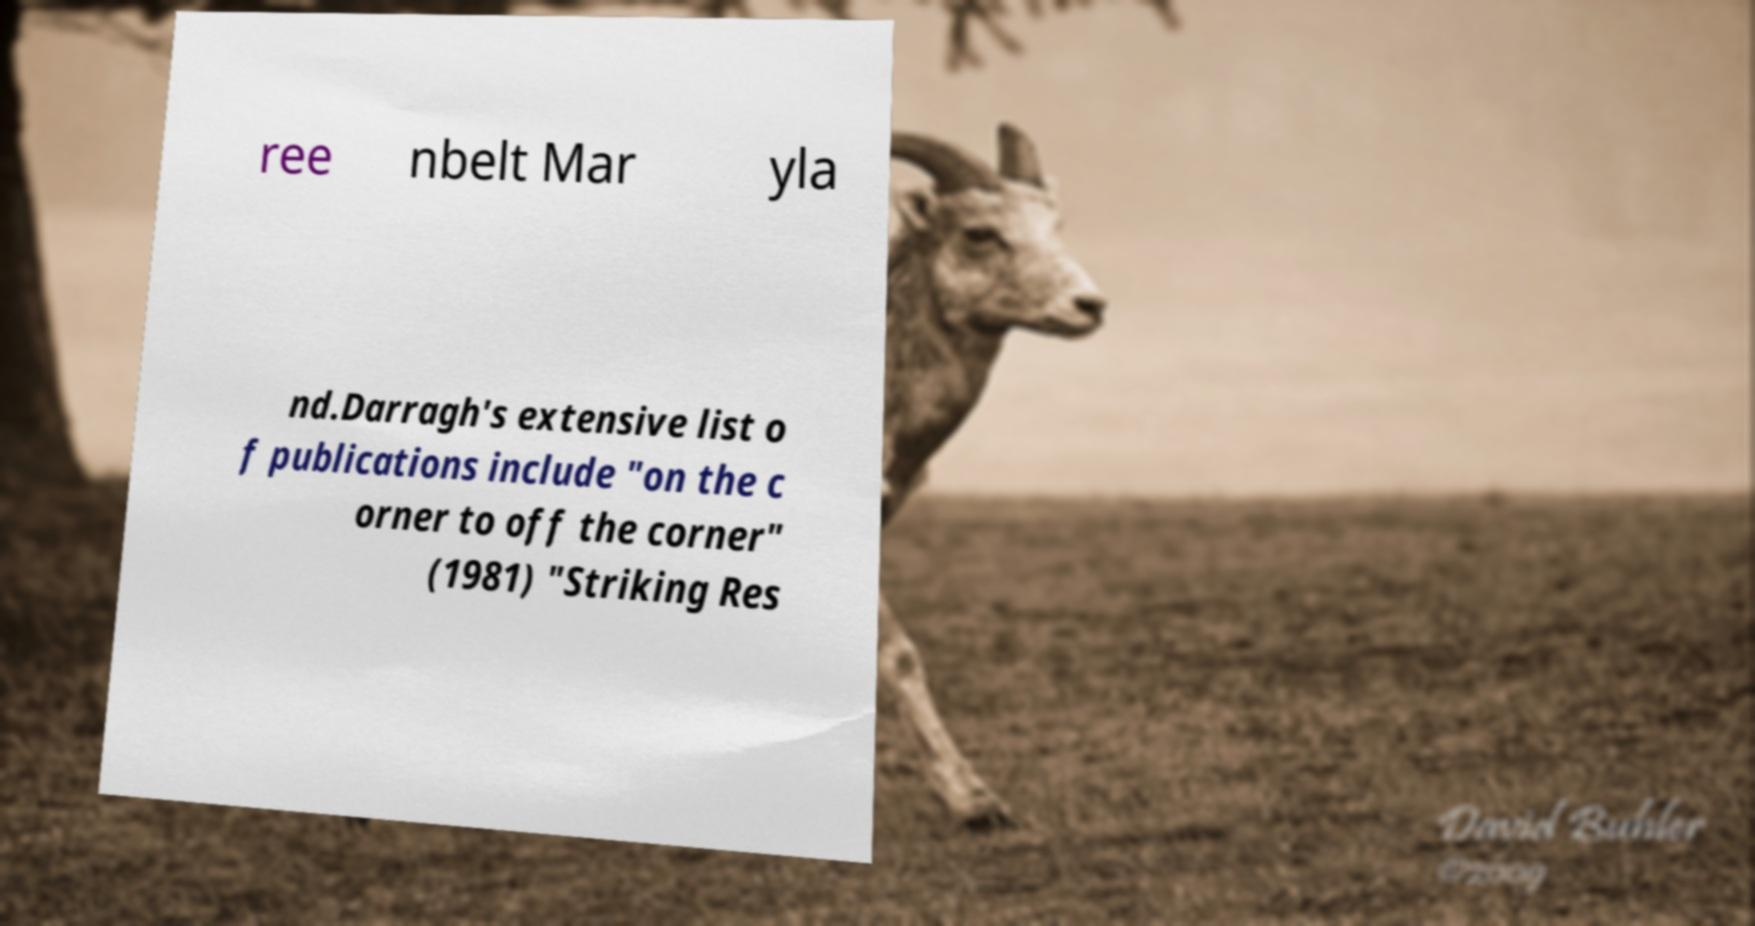For documentation purposes, I need the text within this image transcribed. Could you provide that? ree nbelt Mar yla nd.Darragh's extensive list o f publications include "on the c orner to off the corner" (1981) "Striking Res 